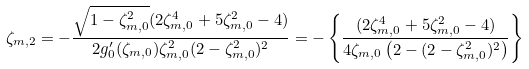<formula> <loc_0><loc_0><loc_500><loc_500>\zeta _ { m , 2 } = - \frac { \sqrt { 1 - \zeta _ { m , 0 } ^ { 2 } } ( 2 \zeta _ { m , 0 } ^ { 4 } + 5 \zeta _ { m , 0 } ^ { 2 } - 4 ) } { 2 g _ { 0 } ^ { \prime } ( \zeta _ { m , 0 } ) \zeta _ { m , 0 } ^ { 2 } ( 2 - \zeta _ { m , 0 } ^ { 2 } ) ^ { 2 } } = - \left \{ \frac { ( 2 \zeta _ { m , 0 } ^ { 4 } + 5 \zeta _ { m , 0 } ^ { 2 } - 4 ) } { 4 \zeta _ { m , 0 } \left ( 2 - ( 2 - \zeta _ { m , 0 } ^ { 2 } ) ^ { 2 } \right ) } \right \}</formula> 